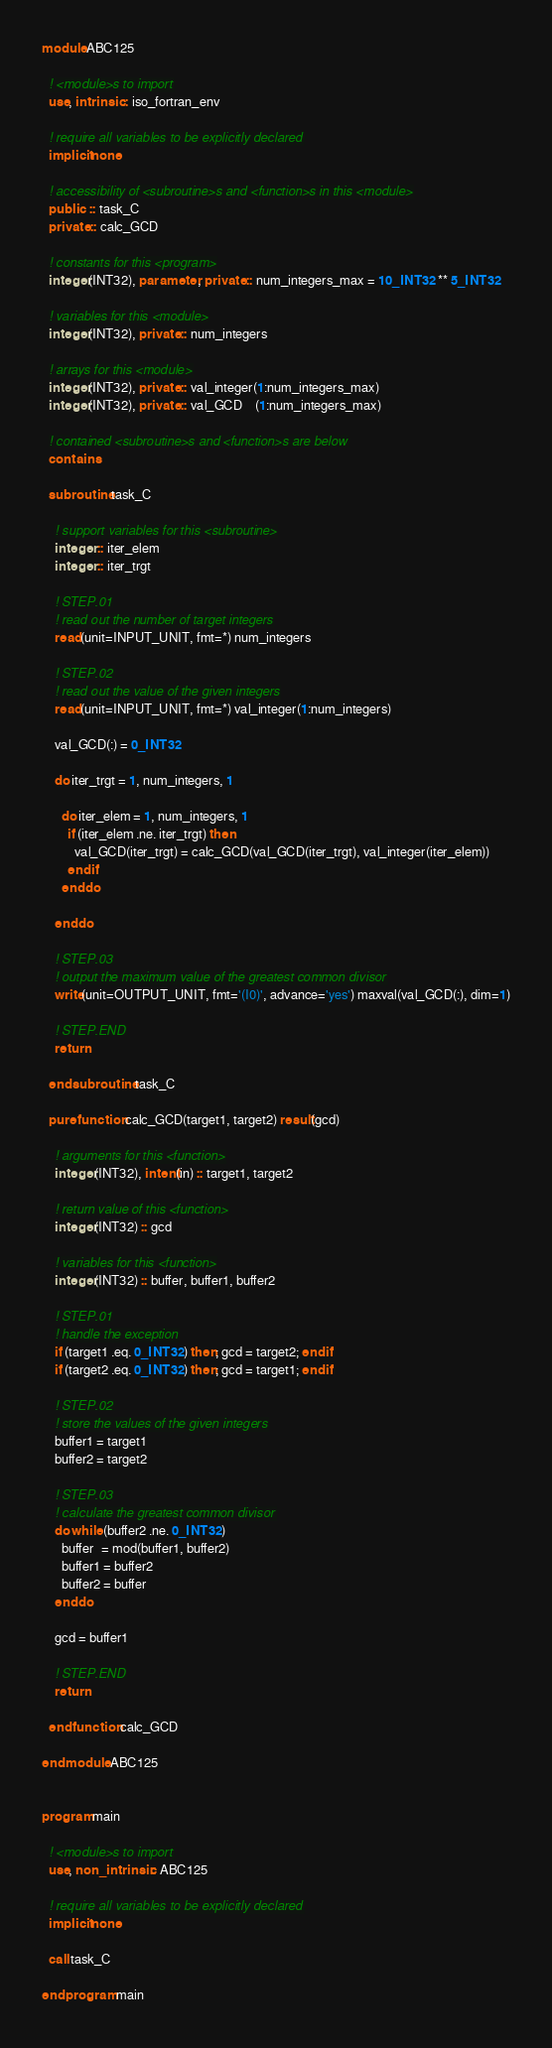Convert code to text. <code><loc_0><loc_0><loc_500><loc_500><_FORTRAN_>module ABC125

  ! <module>s to import
  use, intrinsic :: iso_fortran_env

  ! require all variables to be explicitly declared
  implicit none

  ! accessibility of <subroutine>s and <function>s in this <module>
  public  :: task_C
  private :: calc_GCD

  ! constants for this <program>
  integer(INT32), parameter, private :: num_integers_max = 10_INT32 ** 5_INT32

  ! variables for this <module>
  integer(INT32), private :: num_integers

  ! arrays for this <module>
  integer(INT32), private :: val_integer(1:num_integers_max)
  integer(INT32), private :: val_GCD    (1:num_integers_max)

  ! contained <subroutine>s and <function>s are below
  contains

  subroutine task_C

    ! support variables for this <subroutine>
    integer :: iter_elem
    integer :: iter_trgt

    ! STEP.01
    ! read out the number of target integers
    read(unit=INPUT_UNIT, fmt=*) num_integers

    ! STEP.02
    ! read out the value of the given integers
    read(unit=INPUT_UNIT, fmt=*) val_integer(1:num_integers)

    val_GCD(:) = 0_INT32

    do iter_trgt = 1, num_integers, 1

      do iter_elem = 1, num_integers, 1
        if (iter_elem .ne. iter_trgt) then
          val_GCD(iter_trgt) = calc_GCD(val_GCD(iter_trgt), val_integer(iter_elem))
        end if
      end do

    end do

    ! STEP.03
    ! output the maximum value of the greatest common divisor
    write(unit=OUTPUT_UNIT, fmt='(I0)', advance='yes') maxval(val_GCD(:), dim=1)

    ! STEP.END
    return

  end subroutine task_C

  pure function calc_GCD(target1, target2) result(gcd)

    ! arguments for this <function>
    integer(INT32), intent(in) :: target1, target2

    ! return value of this <function>
    integer(INT32) :: gcd

    ! variables for this <function>
    integer(INT32) :: buffer, buffer1, buffer2

    ! STEP.01
    ! handle the exception
    if (target1 .eq. 0_INT32) then; gcd = target2; end if
    if (target2 .eq. 0_INT32) then; gcd = target1; end if

    ! STEP.02
    ! store the values of the given integers
    buffer1 = target1
    buffer2 = target2

    ! STEP.03
    ! calculate the greatest common divisor
    do while (buffer2 .ne. 0_INT32)
      buffer  = mod(buffer1, buffer2)
      buffer1 = buffer2
      buffer2 = buffer
    end do

    gcd = buffer1

    ! STEP.END
    return

  end function calc_GCD

end module ABC125


program main

  ! <module>s to import
  use, non_intrinsic :: ABC125

  ! require all variables to be explicitly declared
  implicit none

  call task_C

end program main</code> 